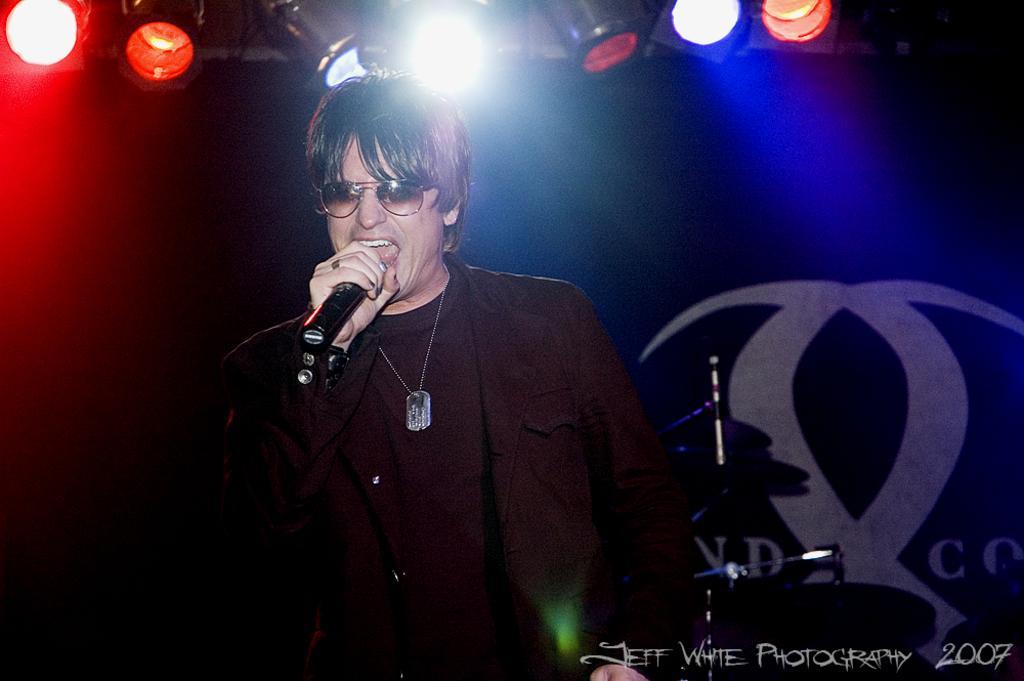How would you summarize this image in a sentence or two? Here is the man standing and singing a song by holding the mike. These are the show lights at the top. At background I can see some instruments. 